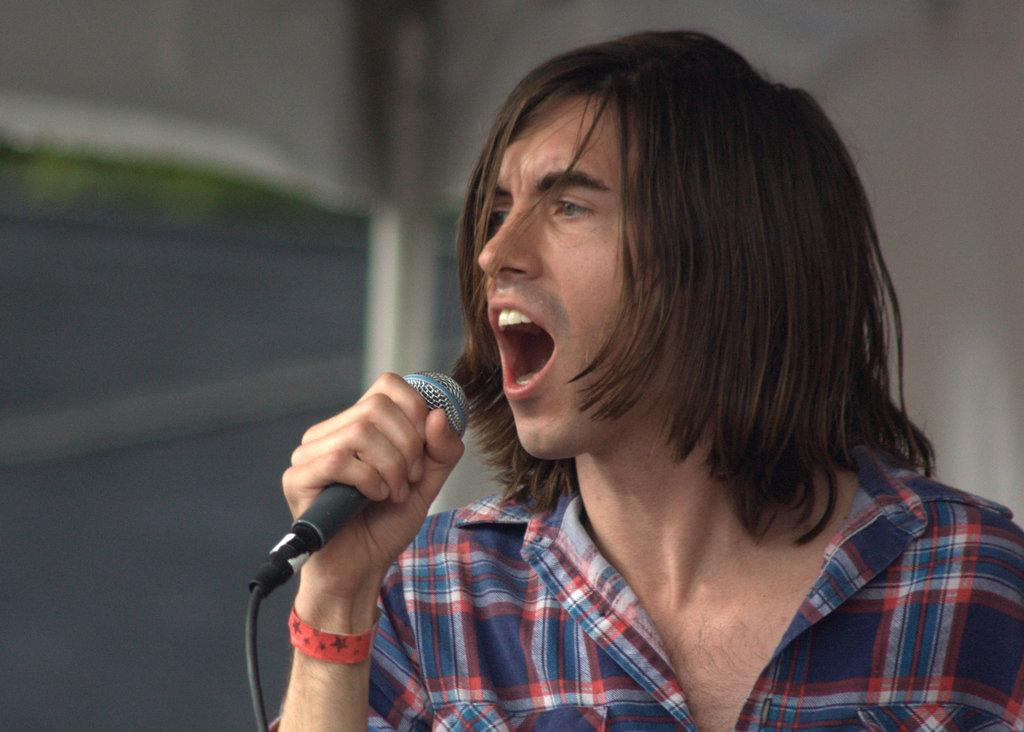What is the main subject of the image? There is a person standing in the center of the image. What is the person holding in the image? The person is holding a microphone. What can be seen in the background of the image? There is a wall in the background of the image. Where is the hydrant located in the image? There is no hydrant present in the image. Is the person taking a bath in the image? There is no indication of a bath or any water-related activity in the image. 